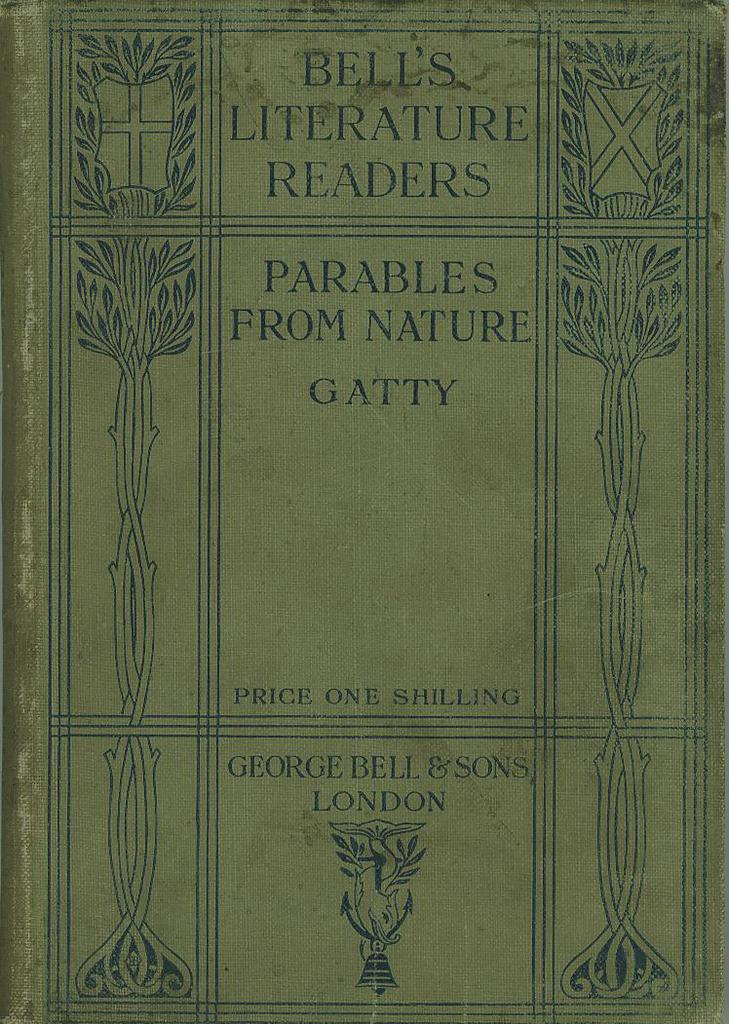<image>
Relay a brief, clear account of the picture shown. The book is one of Bell's Literature Readers with a price of one shilling. 